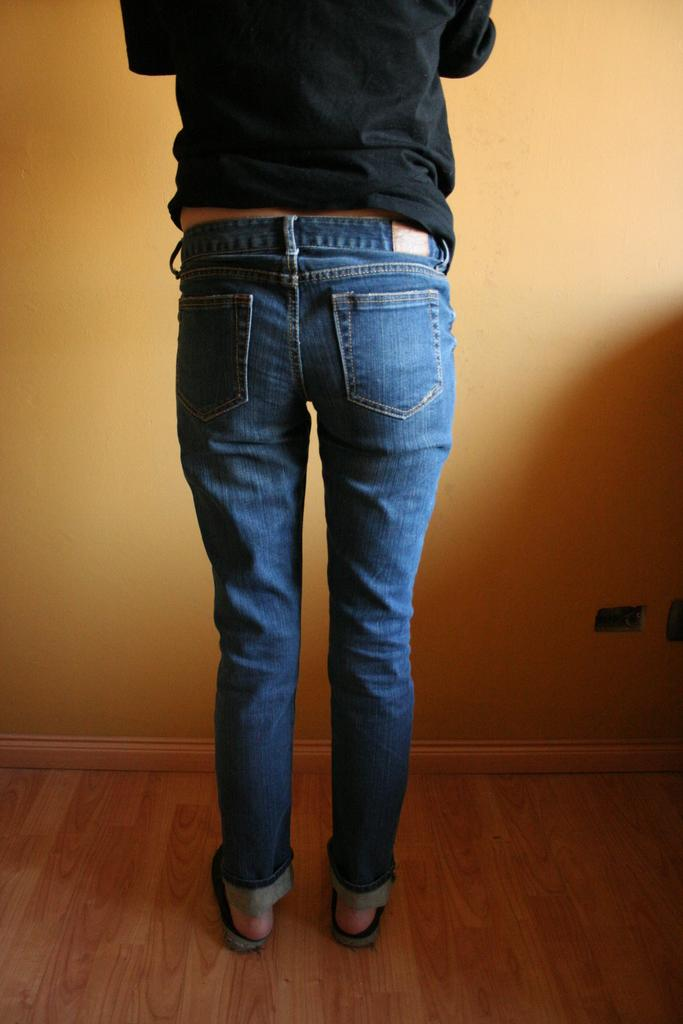What is the main subject of the image? There is a person in the image. What is the person doing in the image? The person is standing in the image. What direction is the person facing? The person is facing a wall in the image. What color is the person's shirt? The person is wearing a black shirt in the image. What color are the person's jeans? The person is wearing blue jeans in the image. What type of religious symbol can be seen on the person's forehead in the image? There is no religious symbol visible on the person's forehead in the image. How does the person maintain their balance while standing in the image? The person's balance is not mentioned or depicted in the image, as they are simply standing. 